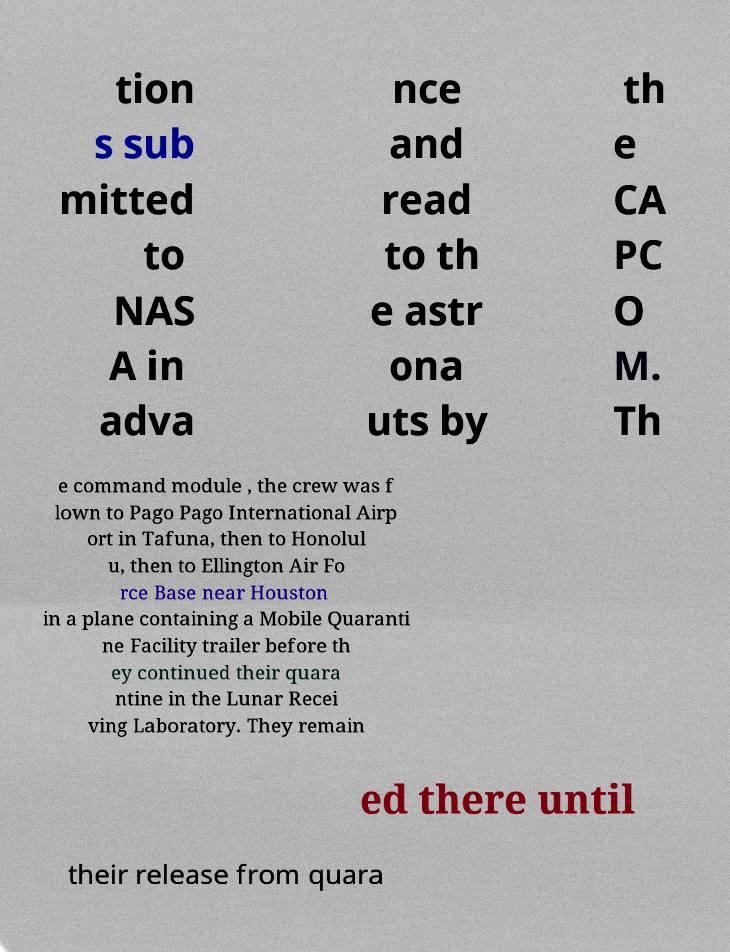For documentation purposes, I need the text within this image transcribed. Could you provide that? tion s sub mitted to NAS A in adva nce and read to th e astr ona uts by th e CA PC O M. Th e command module , the crew was f lown to Pago Pago International Airp ort in Tafuna, then to Honolul u, then to Ellington Air Fo rce Base near Houston in a plane containing a Mobile Quaranti ne Facility trailer before th ey continued their quara ntine in the Lunar Recei ving Laboratory. They remain ed there until their release from quara 